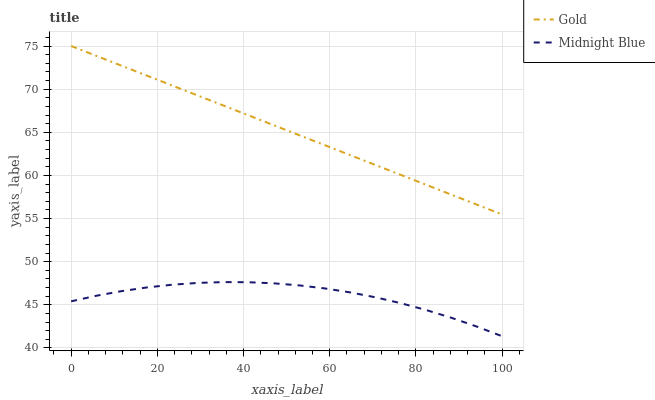Does Gold have the minimum area under the curve?
Answer yes or no. No. Is Gold the roughest?
Answer yes or no. No. Does Gold have the lowest value?
Answer yes or no. No. Is Midnight Blue less than Gold?
Answer yes or no. Yes. Is Gold greater than Midnight Blue?
Answer yes or no. Yes. Does Midnight Blue intersect Gold?
Answer yes or no. No. 